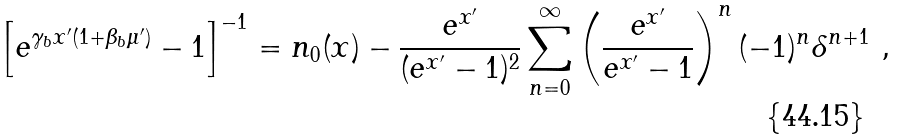Convert formula to latex. <formula><loc_0><loc_0><loc_500><loc_500>\left [ e ^ { \gamma _ { b } x ^ { \prime } ( 1 + \beta _ { b } \mu ^ { \prime } ) } - 1 \right ] ^ { - 1 } = n _ { 0 } ( x ) - \frac { e ^ { x ^ { \prime } } } { ( e ^ { x ^ { \prime } } - 1 ) ^ { 2 } } \sum _ { n = 0 } ^ { \infty } \left ( \frac { e ^ { x ^ { \prime } } } { e ^ { x ^ { \prime } } - 1 } \right ) ^ { n } ( - 1 ) ^ { n } \delta ^ { n + 1 } \ ,</formula> 